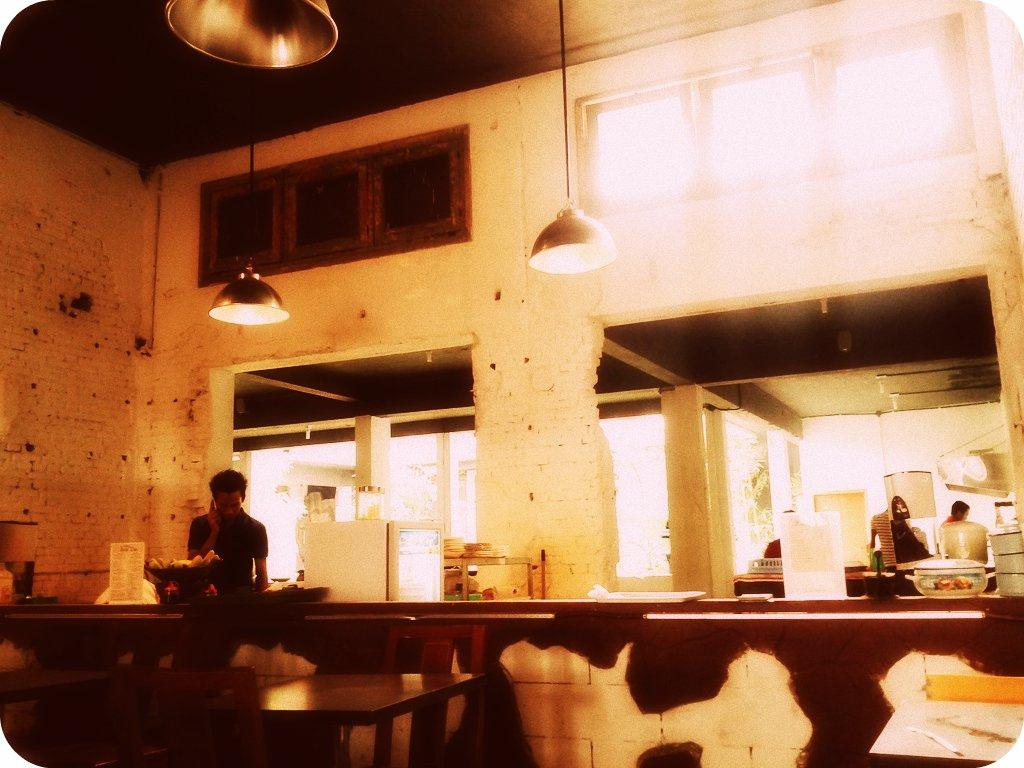What is the main subject in the image? There is a man standing in the image. What can be seen on the table in the image? There is a card, a bowl, and a tray on the table in the image. Are there any other people in the image? Yes, there is another man standing to the right in the image. What other objects are present in the image? There are boxes, lights, and a tree in the image. What type of office can be seen in the image? There is no office present in the image. What type of cow is grazing under the tree in the image? There is no cow present in the image; it only features a tree. 